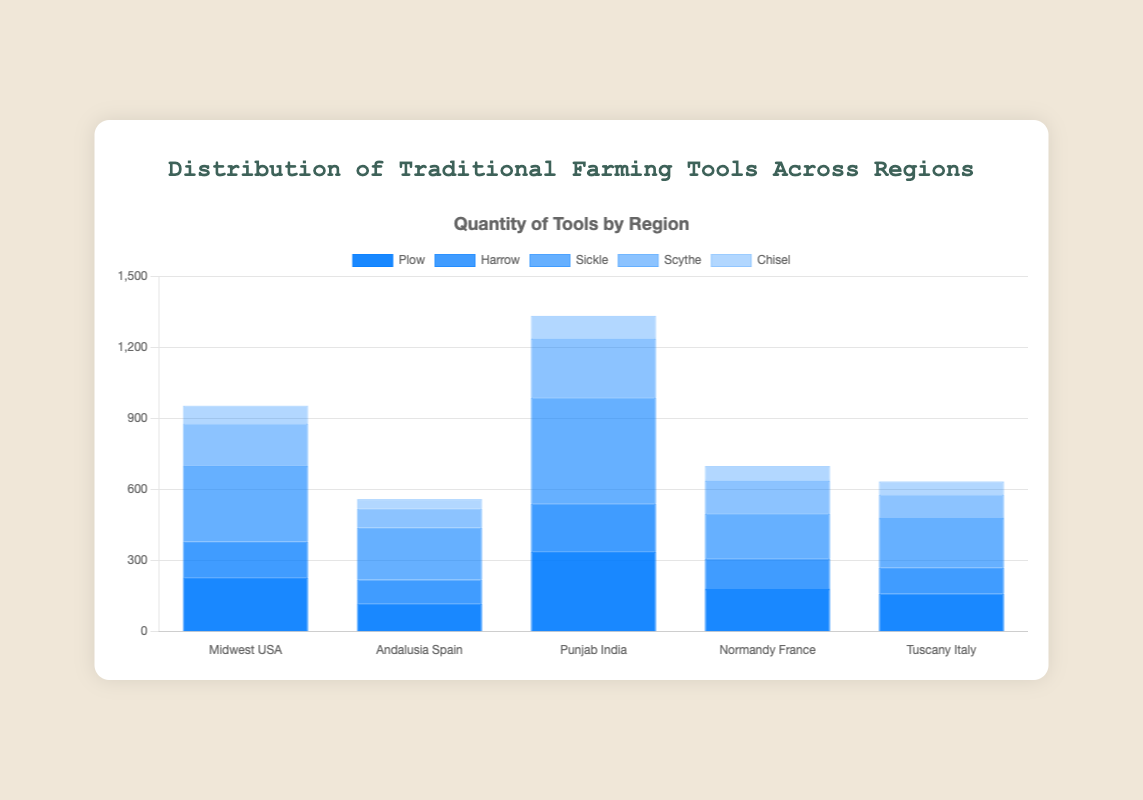Which region uses the most sickles? Check the bar heights for sickles across all regions and identify the tallest bar. Punjab India has the highest bar for sickles with 450 units.
Answer: Punjab India What is the total number of plows used across all regions? Sum the quantities of plows for all regions: 230 (Midwest USA) + 120 (Andalusia Spain) + 340 (Punjab India) + 180 (Normandy France) + 160 (Tuscany Italy) = 1030.
Answer: 1030 Which region has more scythes, Midwest USA or Tuscany Italy? Compare the bar heights for scythes in Midwest USA (180) and Tuscany Italy (100). Midwest USA's bar is taller.
Answer: Midwest USA What is the average number of chisels used per region? Sum the quantities of chisels across all regions and divide by the number of regions: (75 (Midwest USA) + 40 (Andalusia Spain) + 95 (Punjab India) + 60 (Normandy France) + 55 (Tuscany Italy)) / 5 = 65.
Answer: 65 Which tool is used the least in Andalusia Spain? Identify the tool with the shortest bar in Andalusia Spain. The chisel bar is the shortest with 40 units.
Answer: Chisel Compare the total number of harrows in Punjab India to the total number in Normandy France. Which region has more? Compare the quantities: Punjab India (200) and Normandy France (130). Punjab India has more harrows.
Answer: Punjab India What is the difference in the number of sickles between Midwest USA and Andalusia Spain? Subtract t he quantity of sickles in Andalusia Spain (220) from Midwest USA (320): 320 - 220 = 100.
Answer: 100 Among the plows and sickles in Tuscany Italy, which tool is more used and by how much? Compare quantities: Plow (160) and Sickle (210). Sickle is more used by 50 units (210 - 160).
Answer: Sickle by 50 How many more scythes are used in Punjab India compared to Andalusia Spain? Subtract the quantity of scythes in Andalusia Spain (80) from Punjab India (250): 250 - 80 = 170.
Answer: 170 Which region has the second most harrows? List regions by harrow quantities and find the second highest: 200 (Punjab India), 150 (Midwest USA). Midwest USA has the second most with 150 harrows.
Answer: Midwest USA 